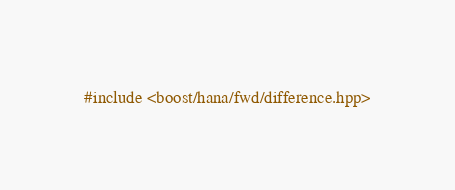Convert code to text. <code><loc_0><loc_0><loc_500><loc_500><_C++_>#include <boost/hana/fwd/difference.hpp>
</code> 